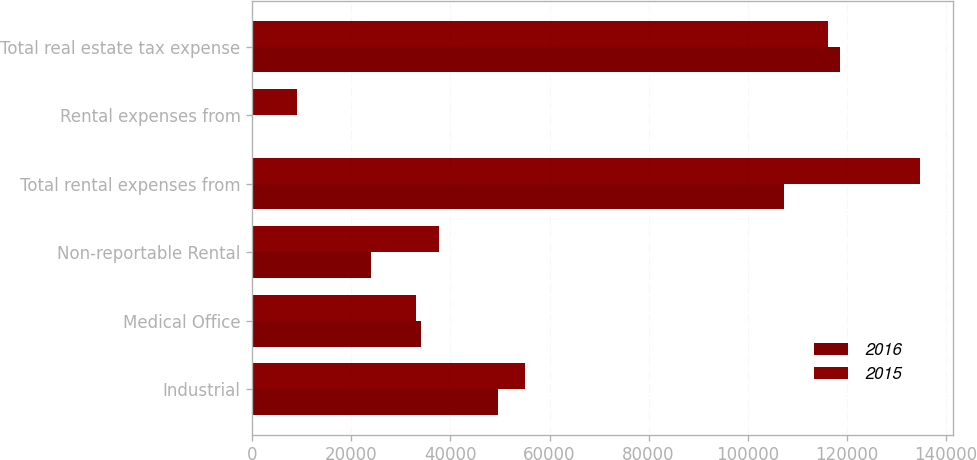Convert chart. <chart><loc_0><loc_0><loc_500><loc_500><stacked_bar_chart><ecel><fcel>Industrial<fcel>Medical Office<fcel>Non-reportable Rental<fcel>Total rental expenses from<fcel>Rental expenses from<fcel>Total real estate tax expense<nl><fcel>2016<fcel>49502<fcel>34023<fcel>23885<fcel>107402<fcel>8<fcel>118654<nl><fcel>2015<fcel>55088<fcel>32955<fcel>37623<fcel>134729<fcel>9063<fcel>116314<nl></chart> 